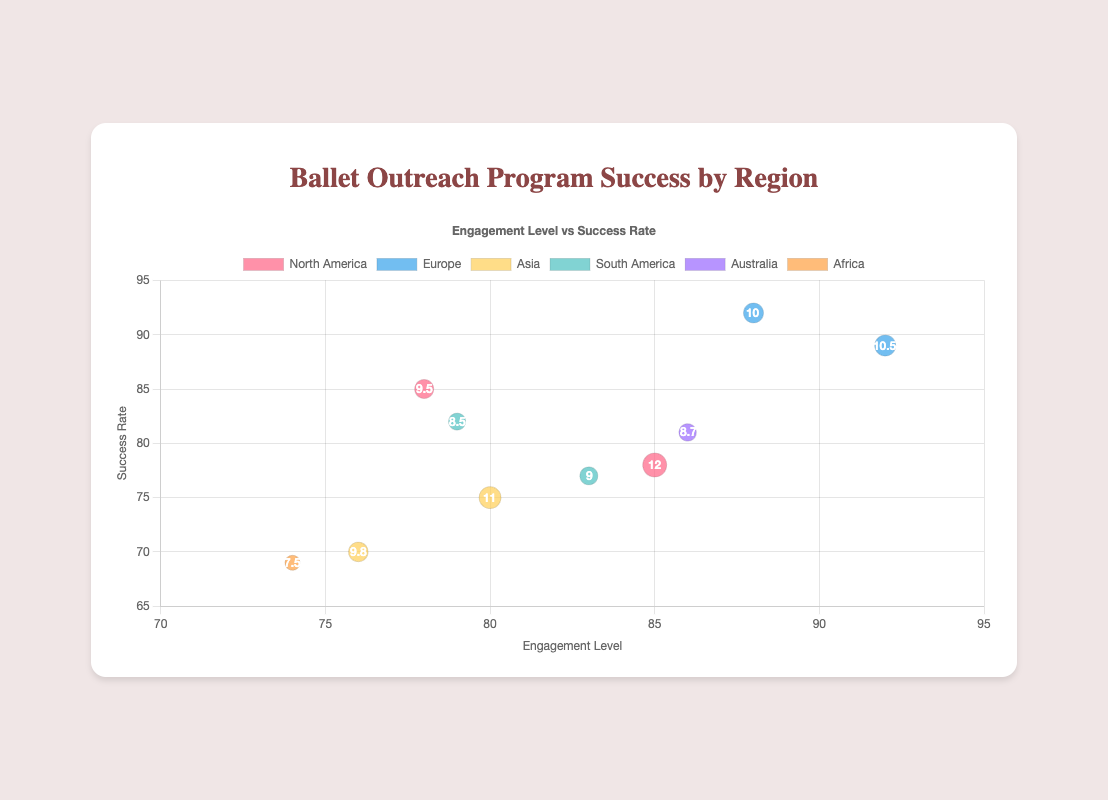How many regions are represented in the chart? The chart includes datasets for the following regions: North America, Europe, Asia, South America, Australia, and Africa. Count each uniquely labeled dataset.
Answer: 6 What is the engagement level for the city with the highest success rate in North America? In North America's dataset, check the success rates and find the highest value, then note the corresponding engagement level. Los Angeles has the highest success rate (85%) and the engagement level is 78.
Answer: 78 What is the average success rate of European cities? Sum the success rates of the European cities (London: 89, Paris: 92) and divide by the number of cities. The calculation is (89 + 92) / 2 = 90.5.
Answer: 90.5 Compare the size of bubbles between Tokyo and Los Angeles. Which city has a larger bubble? Check each city's bubble size (denoted by "r" value). Tokyo has an "r" of 11, and Los Angeles has an "r" of 9.5. Tokyo's bubble is larger.
Answer: Tokyo Which city in Asia has the lowest success rate? In the Asia dataset, find the city with the lowest success rate by comparing the values. Beijing has the lowest success rate at 70%.
Answer: Beijing What is the relationship between engagement level and success rate in the chart? Look at the overall trend by observing the data points; most cities with higher engagement levels also have high success rates.
Answer: Positive correlation How many participants are represented by the largest bubble? The size of the bubble is proportional to the number of participants. The largest bubble ("r" = 12) represents 120 participants, which is New York.
Answer: 120 Which region has the city with the highest engagement level? Identify the highest engagement level first (92, London), then check the corresponding region, which is Europe.
Answer: Europe Compare the success rates of Sydney and Cape Town. Which city has a higher success rate? Locate the success rates for each city, Sydney (81) and Cape Town (69). Sydney has a higher success rate at 81%.
Answer: Sydney What is the difference in engagement levels between Buenos Aires and São Paulo? Subtract the engagement level of Buenos Aires from São Paulo. The engagement levels are 79 (Buenos Aires) and 83 (São Paulo). The difference is 83 - 79 = 4.
Answer: 4 